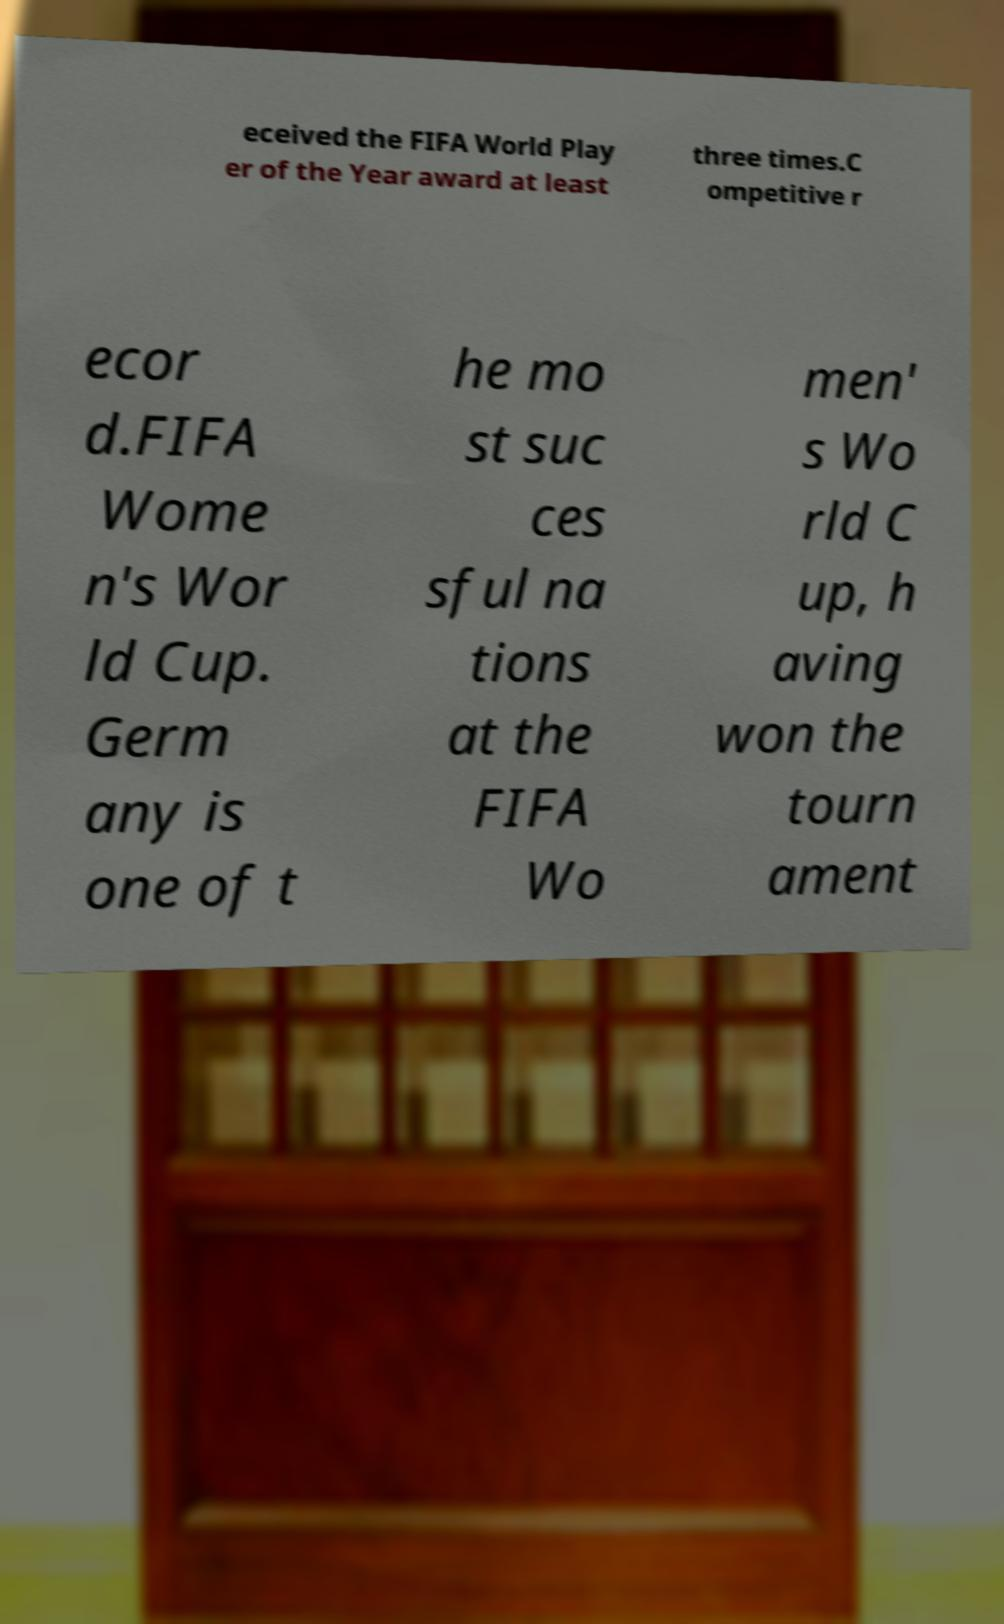Please identify and transcribe the text found in this image. eceived the FIFA World Play er of the Year award at least three times.C ompetitive r ecor d.FIFA Wome n's Wor ld Cup. Germ any is one of t he mo st suc ces sful na tions at the FIFA Wo men' s Wo rld C up, h aving won the tourn ament 